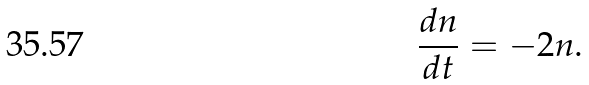<formula> <loc_0><loc_0><loc_500><loc_500>\frac { d n } { d t } = - 2 n .</formula> 